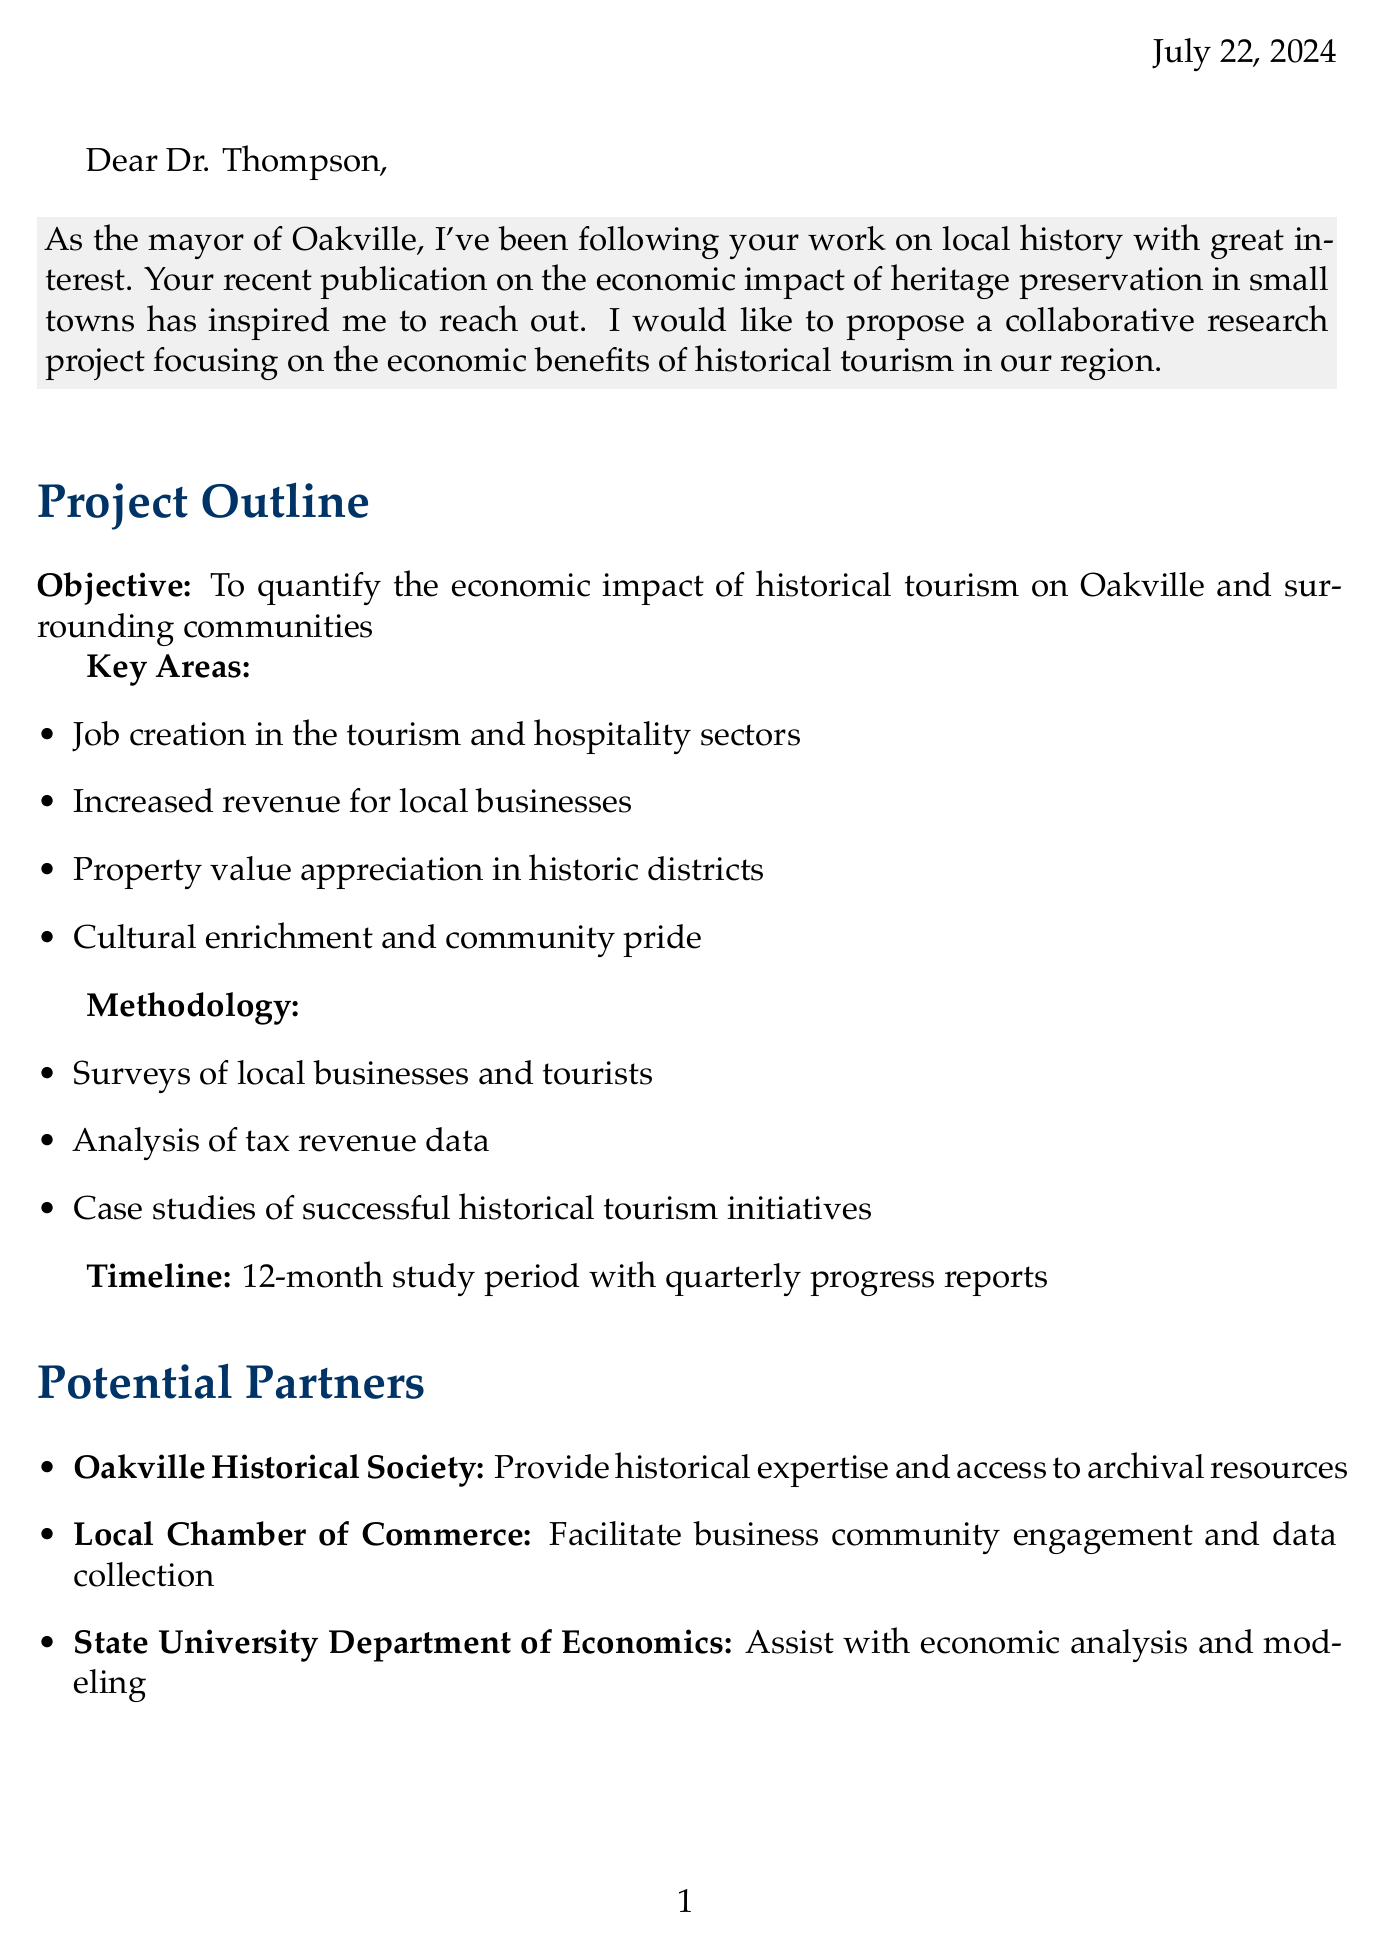What is the objective of the proposed project? The objective is to quantify the economic impact of historical tourism on Oakville and surrounding communities.
Answer: To quantify the economic impact of historical tourism on Oakville and surrounding communities Who is proposed as a partner organization to provide historical expertise? The letter lists organizations along with their roles, and the Oakville Historical Society is specifically mentioned for historical expertise.
Answer: Oakville Historical Society How long is the study period for the project? The timeline section of the document specifies that the study period is 12 months.
Answer: 12 months What are the key areas of focus for the project? The document lists several key areas, one of which is job creation in the tourism and hospitality sectors.
Answer: Job creation in the tourism and hospitality sectors Which funding source is related to heritage tourism development? Among the funding sources, the State Tourism Board is associated with heritage tourism development funding.
Answer: State Tourism Board What is an expected outcome of the study? The document mentions several expected outcomes, including a comprehensive report on the economic impact of historical tourism.
Answer: Comprehensive report on the economic impact of historical tourism What is the main call to action in the letter? The call to action expresses a desire to discuss the proposal in person.
Answer: Discuss this proposal with you in person Who is the sender of the letter? The letter includes a signature that identifies the sender.
Answer: Mayor Sarah Jenkins What methodology will be used in the research? The methodology section lists various methods, including surveys of local businesses and tourists.
Answer: Surveys of local businesses and tourists 